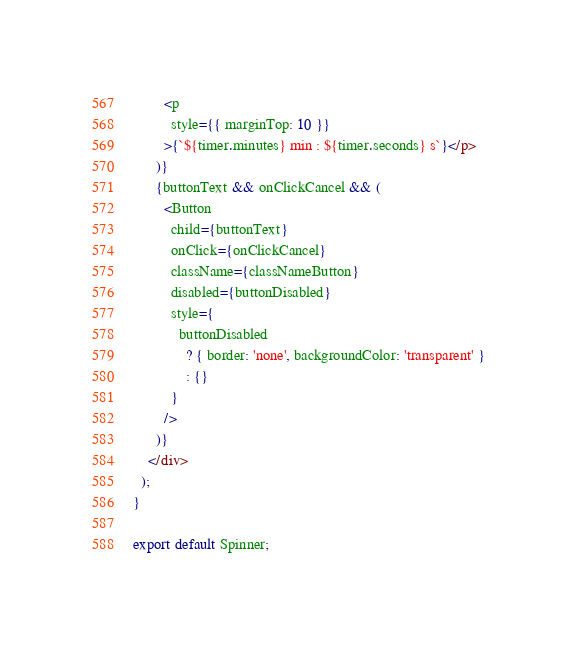<code> <loc_0><loc_0><loc_500><loc_500><_TypeScript_>        <p
          style={{ marginTop: 10 }}
        >{`${timer.minutes} min : ${timer.seconds} s`}</p>
      )}
      {buttonText && onClickCancel && (
        <Button
          child={buttonText}
          onClick={onClickCancel}
          className={classNameButton}
          disabled={buttonDisabled}
          style={
            buttonDisabled
              ? { border: 'none', backgroundColor: 'transparent' }
              : {}
          }
        />
      )}
    </div>
  );
}

export default Spinner;
</code> 